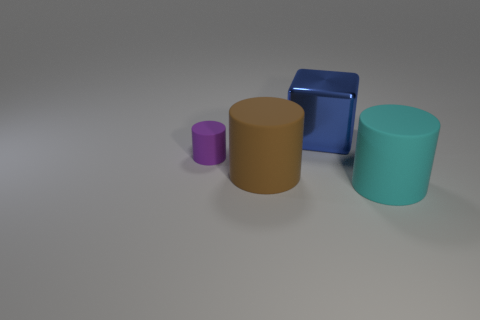What is the size of the cylinder that is to the left of the big rubber object to the left of the large matte cylinder that is on the right side of the large blue object?
Keep it short and to the point. Small. Do the big cyan object and the large object behind the brown matte thing have the same material?
Make the answer very short. No. Is the shape of the large cyan rubber object the same as the small purple matte object?
Provide a short and direct response. Yes. How many other things are there of the same material as the small purple object?
Your response must be concise. 2. What number of large brown objects are the same shape as the large cyan thing?
Provide a short and direct response. 1. What is the color of the thing that is behind the large brown matte cylinder and in front of the large blue metallic cube?
Your response must be concise. Purple. How many tiny blue cubes are there?
Ensure brevity in your answer.  0. Do the shiny cube and the brown matte cylinder have the same size?
Offer a terse response. Yes. Is there a matte thing of the same color as the metal thing?
Make the answer very short. No. There is a matte object that is in front of the brown cylinder; is its shape the same as the purple thing?
Offer a very short reply. Yes. 